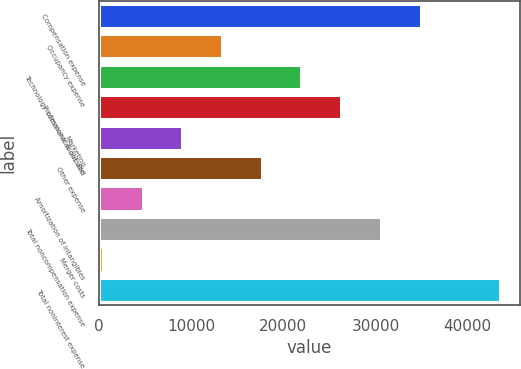<chart> <loc_0><loc_0><loc_500><loc_500><bar_chart><fcel>Compensation expense<fcel>Occupancy expense<fcel>Technology communications and<fcel>Professional & outside<fcel>Marketing<fcel>Other expense<fcel>Amortization of intangibles<fcel>Total noncompensation expense<fcel>Merger costs<fcel>Total noninterest expense<nl><fcel>34886.4<fcel>13352.4<fcel>21966<fcel>26272.8<fcel>9045.6<fcel>17659.2<fcel>4738.8<fcel>30579.6<fcel>432<fcel>43500<nl></chart> 